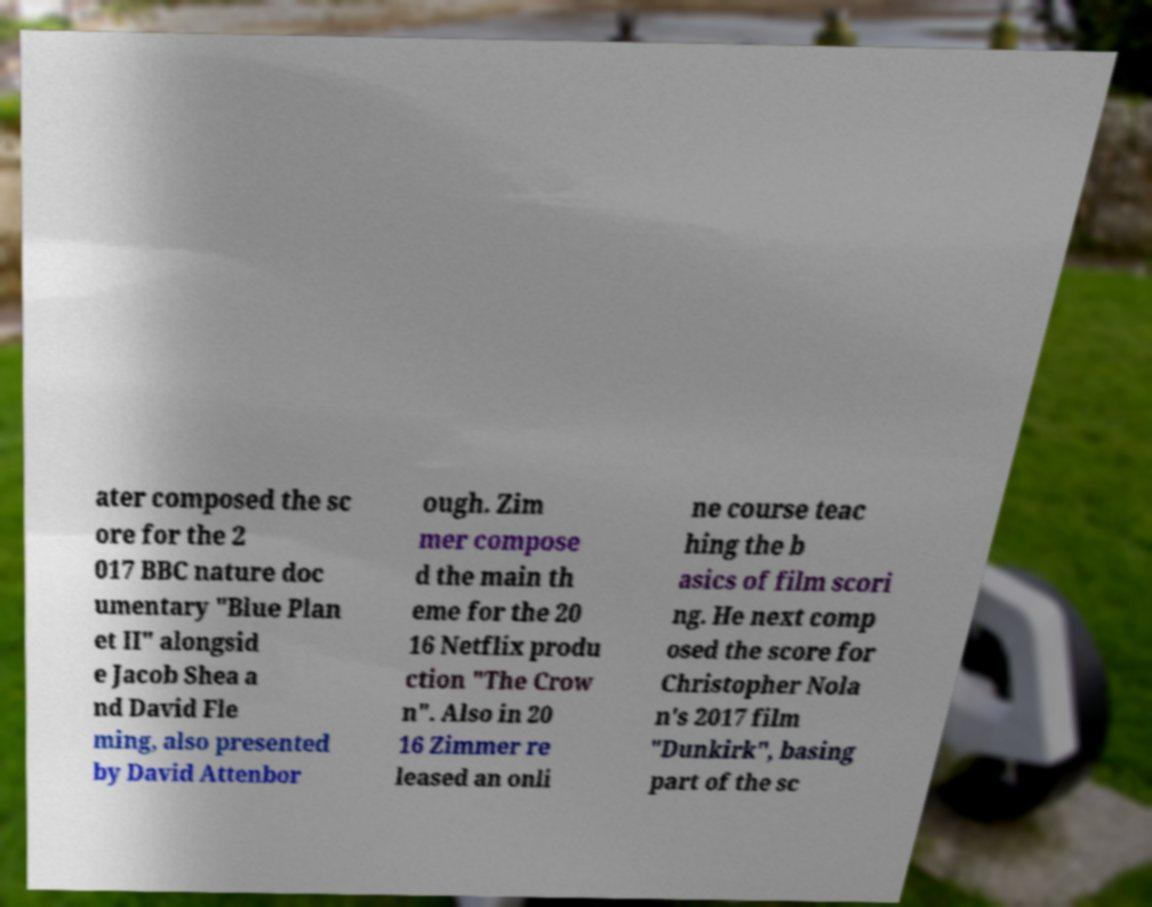What messages or text are displayed in this image? I need them in a readable, typed format. ater composed the sc ore for the 2 017 BBC nature doc umentary "Blue Plan et II" alongsid e Jacob Shea a nd David Fle ming, also presented by David Attenbor ough. Zim mer compose d the main th eme for the 20 16 Netflix produ ction "The Crow n". Also in 20 16 Zimmer re leased an onli ne course teac hing the b asics of film scori ng. He next comp osed the score for Christopher Nola n's 2017 film "Dunkirk", basing part of the sc 